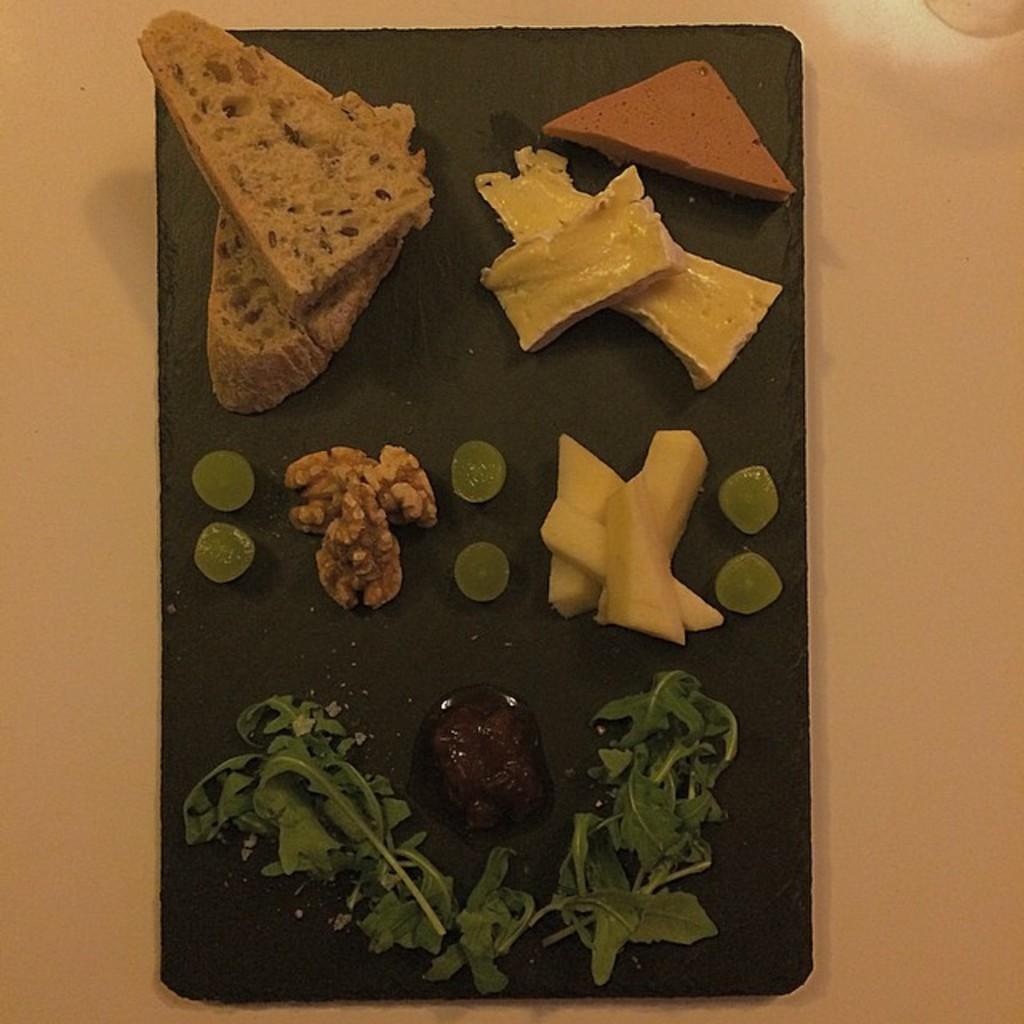Could you give a brief overview of what you see in this image? In this image there are food items, walnuts, leafy vegetables on the plate on the table. 